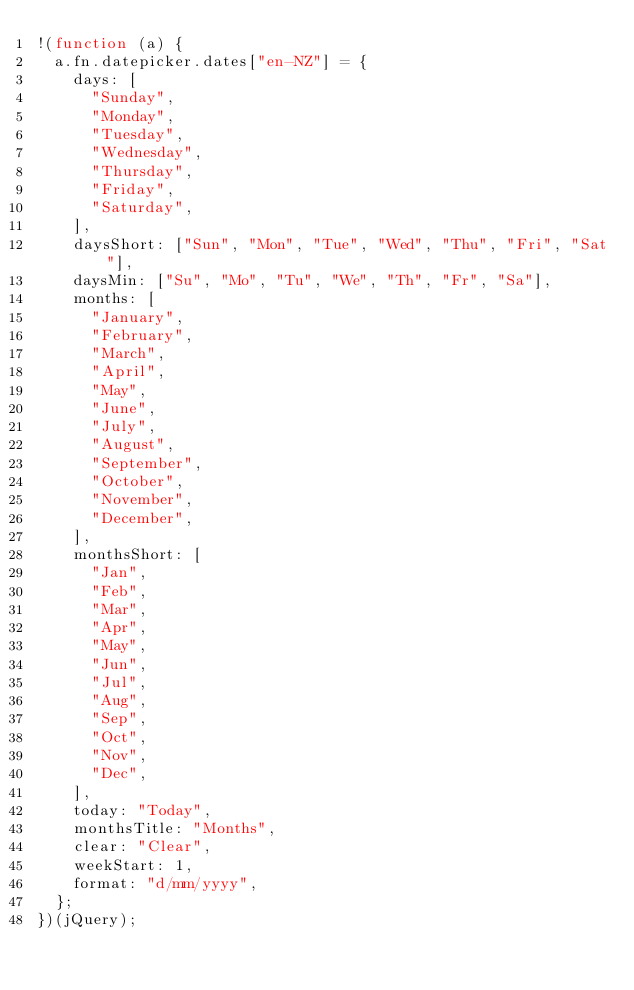<code> <loc_0><loc_0><loc_500><loc_500><_JavaScript_>!(function (a) {
  a.fn.datepicker.dates["en-NZ"] = {
    days: [
      "Sunday",
      "Monday",
      "Tuesday",
      "Wednesday",
      "Thursday",
      "Friday",
      "Saturday",
    ],
    daysShort: ["Sun", "Mon", "Tue", "Wed", "Thu", "Fri", "Sat"],
    daysMin: ["Su", "Mo", "Tu", "We", "Th", "Fr", "Sa"],
    months: [
      "January",
      "February",
      "March",
      "April",
      "May",
      "June",
      "July",
      "August",
      "September",
      "October",
      "November",
      "December",
    ],
    monthsShort: [
      "Jan",
      "Feb",
      "Mar",
      "Apr",
      "May",
      "Jun",
      "Jul",
      "Aug",
      "Sep",
      "Oct",
      "Nov",
      "Dec",
    ],
    today: "Today",
    monthsTitle: "Months",
    clear: "Clear",
    weekStart: 1,
    format: "d/mm/yyyy",
  };
})(jQuery);
</code> 